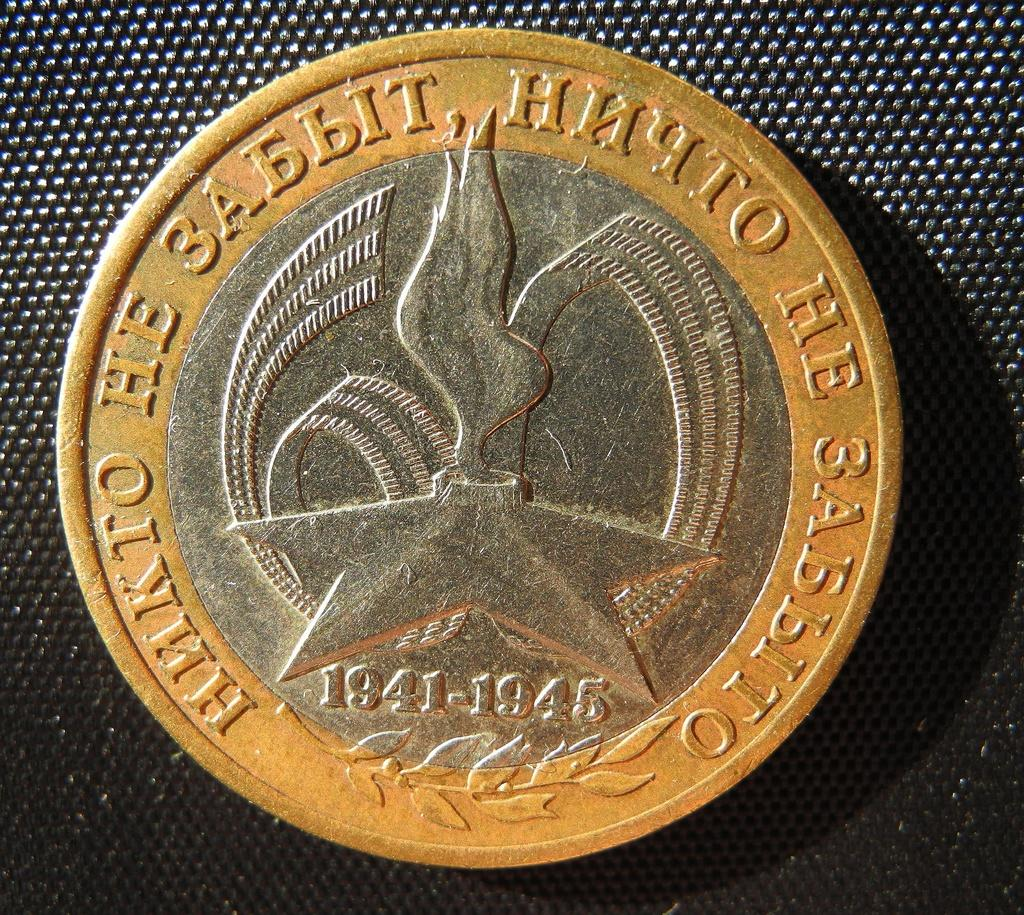<image>
Describe the image concisely. a coin that says 'hnkto he 3abbit' on it 